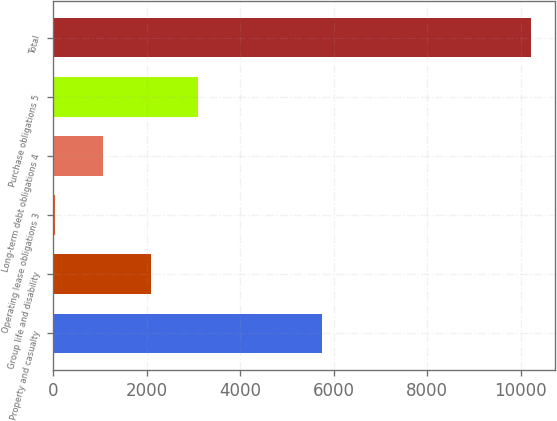Convert chart. <chart><loc_0><loc_0><loc_500><loc_500><bar_chart><fcel>Property and casualty<fcel>Group life and disability<fcel>Operating lease obligations 3<fcel>Long-term debt obligations 4<fcel>Purchase obligations 5<fcel>Total<nl><fcel>5740<fcel>2079.4<fcel>44<fcel>1061.7<fcel>3097.1<fcel>10221<nl></chart> 